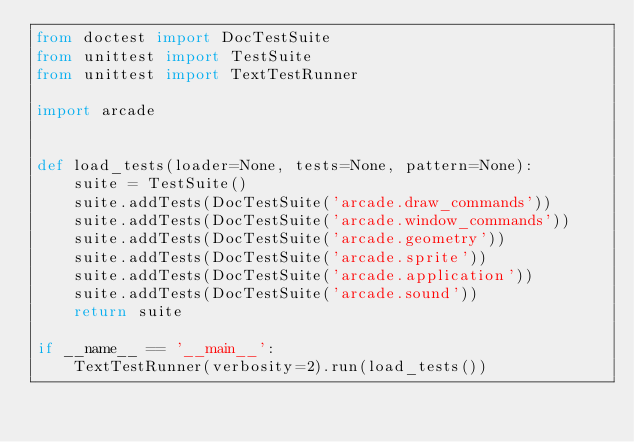Convert code to text. <code><loc_0><loc_0><loc_500><loc_500><_Python_>from doctest import DocTestSuite
from unittest import TestSuite
from unittest import TextTestRunner

import arcade


def load_tests(loader=None, tests=None, pattern=None):
    suite = TestSuite()
    suite.addTests(DocTestSuite('arcade.draw_commands'))
    suite.addTests(DocTestSuite('arcade.window_commands'))
    suite.addTests(DocTestSuite('arcade.geometry'))
    suite.addTests(DocTestSuite('arcade.sprite'))
    suite.addTests(DocTestSuite('arcade.application'))
    suite.addTests(DocTestSuite('arcade.sound'))
    return suite

if __name__ == '__main__':
    TextTestRunner(verbosity=2).run(load_tests())
</code> 